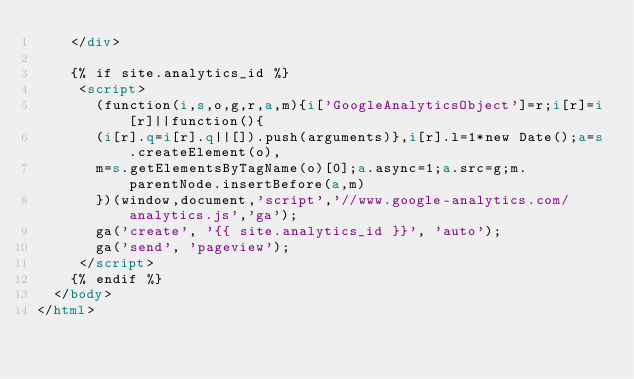<code> <loc_0><loc_0><loc_500><loc_500><_HTML_>    </div>

    {% if site.analytics_id %}
     <script>
       (function(i,s,o,g,r,a,m){i['GoogleAnalyticsObject']=r;i[r]=i[r]||function(){
       (i[r].q=i[r].q||[]).push(arguments)},i[r].l=1*new Date();a=s.createElement(o),
       m=s.getElementsByTagName(o)[0];a.async=1;a.src=g;m.parentNode.insertBefore(a,m)
       })(window,document,'script','//www.google-analytics.com/analytics.js','ga');
       ga('create', '{{ site.analytics_id }}', 'auto');
       ga('send', 'pageview');
     </script>
    {% endif %}
  </body>
</html>
</code> 